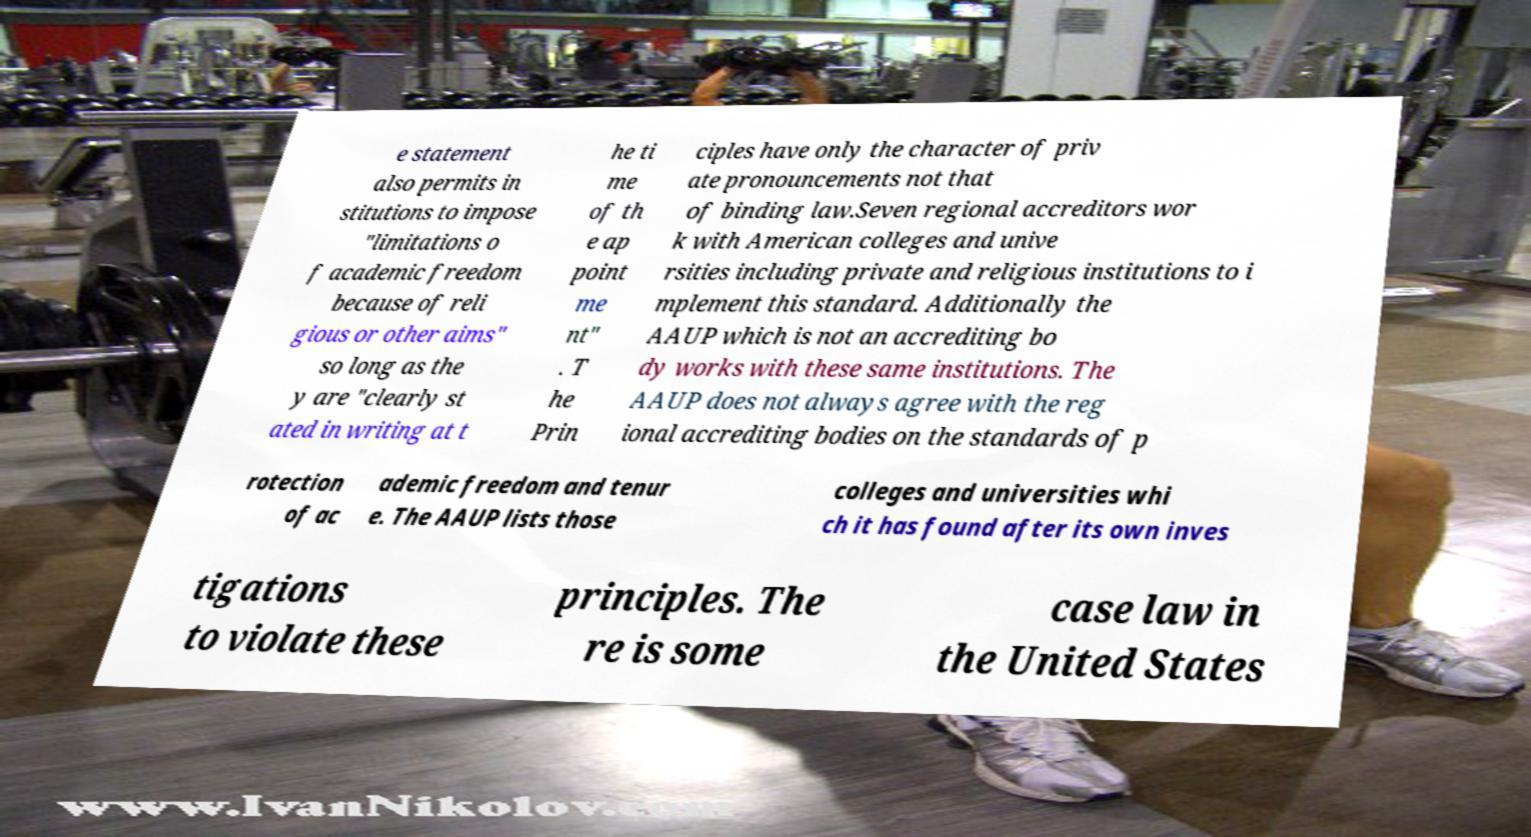Can you read and provide the text displayed in the image?This photo seems to have some interesting text. Can you extract and type it out for me? e statement also permits in stitutions to impose "limitations o f academic freedom because of reli gious or other aims" so long as the y are "clearly st ated in writing at t he ti me of th e ap point me nt" . T he Prin ciples have only the character of priv ate pronouncements not that of binding law.Seven regional accreditors wor k with American colleges and unive rsities including private and religious institutions to i mplement this standard. Additionally the AAUP which is not an accrediting bo dy works with these same institutions. The AAUP does not always agree with the reg ional accrediting bodies on the standards of p rotection of ac ademic freedom and tenur e. The AAUP lists those colleges and universities whi ch it has found after its own inves tigations to violate these principles. The re is some case law in the United States 